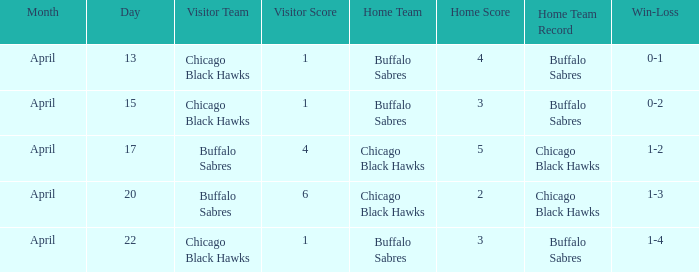When has a Record of 1-3? April 20. 